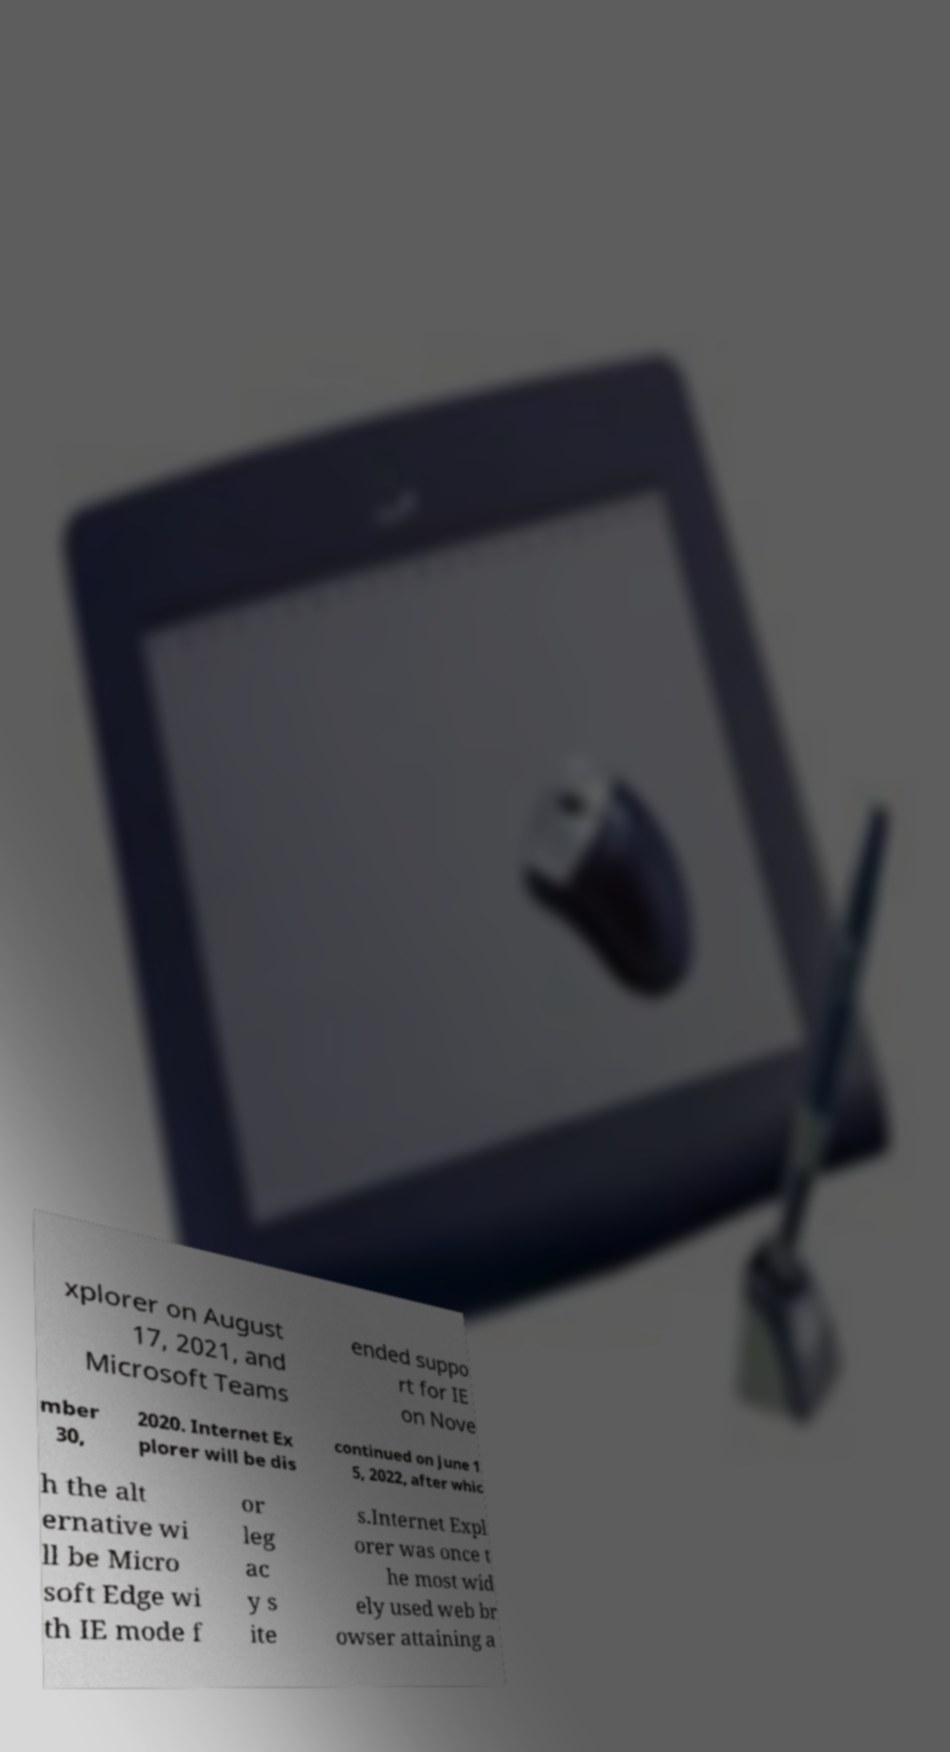Could you extract and type out the text from this image? xplorer on August 17, 2021, and Microsoft Teams ended suppo rt for IE on Nove mber 30, 2020. Internet Ex plorer will be dis continued on June 1 5, 2022, after whic h the alt ernative wi ll be Micro soft Edge wi th IE mode f or leg ac y s ite s.Internet Expl orer was once t he most wid ely used web br owser attaining a 